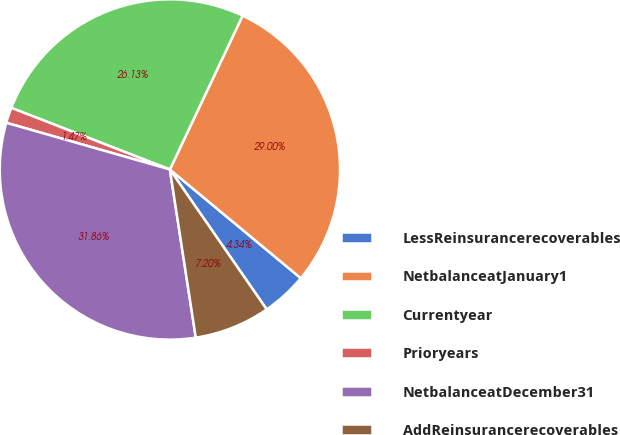Convert chart to OTSL. <chart><loc_0><loc_0><loc_500><loc_500><pie_chart><fcel>LessReinsurancerecoverables<fcel>NetbalanceatJanuary1<fcel>Currentyear<fcel>Prioryears<fcel>NetbalanceatDecember31<fcel>AddReinsurancerecoverables<nl><fcel>4.34%<fcel>29.0%<fcel>26.13%<fcel>1.47%<fcel>31.86%<fcel>7.2%<nl></chart> 